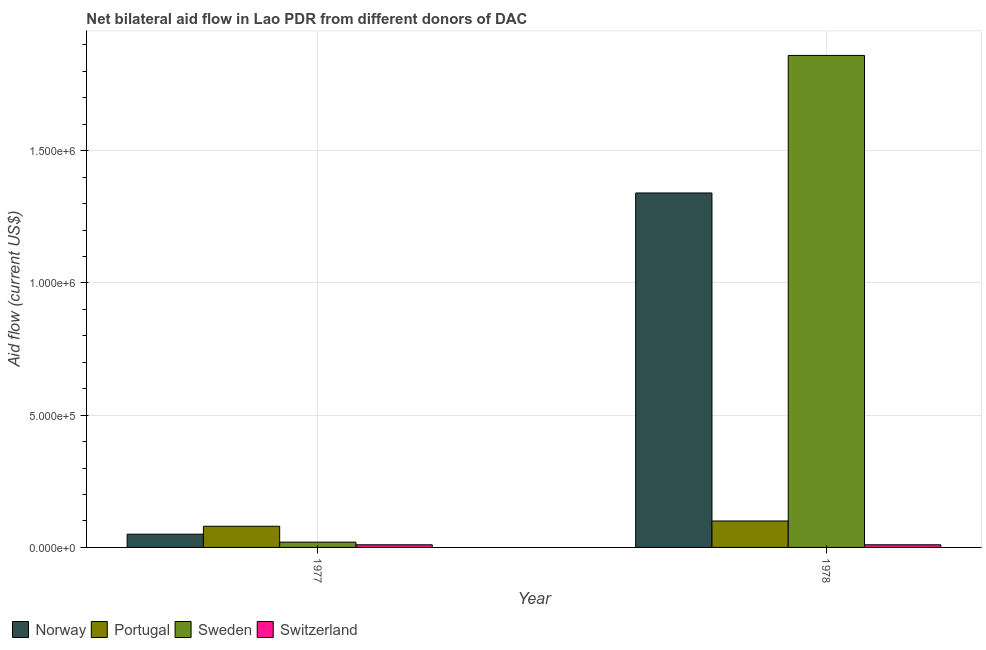How many different coloured bars are there?
Offer a very short reply. 4. How many groups of bars are there?
Provide a short and direct response. 2. How many bars are there on the 2nd tick from the left?
Make the answer very short. 4. What is the label of the 1st group of bars from the left?
Provide a short and direct response. 1977. In how many cases, is the number of bars for a given year not equal to the number of legend labels?
Ensure brevity in your answer.  0. What is the amount of aid given by sweden in 1978?
Your response must be concise. 1.86e+06. Across all years, what is the maximum amount of aid given by norway?
Offer a terse response. 1.34e+06. Across all years, what is the minimum amount of aid given by switzerland?
Your response must be concise. 10000. In which year was the amount of aid given by sweden maximum?
Your response must be concise. 1978. What is the total amount of aid given by switzerland in the graph?
Your response must be concise. 2.00e+04. What is the difference between the amount of aid given by norway in 1977 and that in 1978?
Make the answer very short. -1.29e+06. What is the difference between the amount of aid given by portugal in 1977 and the amount of aid given by sweden in 1978?
Provide a short and direct response. -2.00e+04. What is the average amount of aid given by portugal per year?
Offer a very short reply. 9.00e+04. In how many years, is the amount of aid given by portugal greater than 1300000 US$?
Offer a very short reply. 0. What is the ratio of the amount of aid given by switzerland in 1977 to that in 1978?
Provide a short and direct response. 1. Is the amount of aid given by sweden in 1977 less than that in 1978?
Ensure brevity in your answer.  Yes. In how many years, is the amount of aid given by portugal greater than the average amount of aid given by portugal taken over all years?
Ensure brevity in your answer.  1. Is it the case that in every year, the sum of the amount of aid given by switzerland and amount of aid given by norway is greater than the sum of amount of aid given by portugal and amount of aid given by sweden?
Make the answer very short. No. What does the 3rd bar from the left in 1977 represents?
Provide a succinct answer. Sweden. Is it the case that in every year, the sum of the amount of aid given by norway and amount of aid given by portugal is greater than the amount of aid given by sweden?
Ensure brevity in your answer.  No. How many years are there in the graph?
Give a very brief answer. 2. Does the graph contain any zero values?
Offer a very short reply. No. How are the legend labels stacked?
Make the answer very short. Horizontal. What is the title of the graph?
Keep it short and to the point. Net bilateral aid flow in Lao PDR from different donors of DAC. Does "Social Awareness" appear as one of the legend labels in the graph?
Ensure brevity in your answer.  No. What is the Aid flow (current US$) of Norway in 1977?
Give a very brief answer. 5.00e+04. What is the Aid flow (current US$) of Portugal in 1977?
Make the answer very short. 8.00e+04. What is the Aid flow (current US$) of Norway in 1978?
Provide a succinct answer. 1.34e+06. What is the Aid flow (current US$) of Sweden in 1978?
Your answer should be very brief. 1.86e+06. Across all years, what is the maximum Aid flow (current US$) in Norway?
Keep it short and to the point. 1.34e+06. Across all years, what is the maximum Aid flow (current US$) of Sweden?
Offer a very short reply. 1.86e+06. Across all years, what is the maximum Aid flow (current US$) of Switzerland?
Your response must be concise. 10000. Across all years, what is the minimum Aid flow (current US$) in Norway?
Your response must be concise. 5.00e+04. What is the total Aid flow (current US$) of Norway in the graph?
Ensure brevity in your answer.  1.39e+06. What is the total Aid flow (current US$) in Portugal in the graph?
Your answer should be compact. 1.80e+05. What is the total Aid flow (current US$) of Sweden in the graph?
Provide a short and direct response. 1.88e+06. What is the total Aid flow (current US$) of Switzerland in the graph?
Keep it short and to the point. 2.00e+04. What is the difference between the Aid flow (current US$) in Norway in 1977 and that in 1978?
Keep it short and to the point. -1.29e+06. What is the difference between the Aid flow (current US$) of Sweden in 1977 and that in 1978?
Your answer should be very brief. -1.84e+06. What is the difference between the Aid flow (current US$) of Switzerland in 1977 and that in 1978?
Provide a succinct answer. 0. What is the difference between the Aid flow (current US$) of Norway in 1977 and the Aid flow (current US$) of Portugal in 1978?
Your answer should be very brief. -5.00e+04. What is the difference between the Aid flow (current US$) in Norway in 1977 and the Aid flow (current US$) in Sweden in 1978?
Keep it short and to the point. -1.81e+06. What is the difference between the Aid flow (current US$) of Portugal in 1977 and the Aid flow (current US$) of Sweden in 1978?
Your answer should be very brief. -1.78e+06. What is the average Aid flow (current US$) in Norway per year?
Offer a very short reply. 6.95e+05. What is the average Aid flow (current US$) of Portugal per year?
Give a very brief answer. 9.00e+04. What is the average Aid flow (current US$) in Sweden per year?
Keep it short and to the point. 9.40e+05. What is the average Aid flow (current US$) in Switzerland per year?
Your answer should be compact. 10000. In the year 1977, what is the difference between the Aid flow (current US$) in Norway and Aid flow (current US$) in Portugal?
Your answer should be compact. -3.00e+04. In the year 1977, what is the difference between the Aid flow (current US$) in Norway and Aid flow (current US$) in Sweden?
Offer a terse response. 3.00e+04. In the year 1977, what is the difference between the Aid flow (current US$) of Norway and Aid flow (current US$) of Switzerland?
Make the answer very short. 4.00e+04. In the year 1977, what is the difference between the Aid flow (current US$) in Portugal and Aid flow (current US$) in Switzerland?
Give a very brief answer. 7.00e+04. In the year 1977, what is the difference between the Aid flow (current US$) in Sweden and Aid flow (current US$) in Switzerland?
Provide a short and direct response. 10000. In the year 1978, what is the difference between the Aid flow (current US$) in Norway and Aid flow (current US$) in Portugal?
Offer a terse response. 1.24e+06. In the year 1978, what is the difference between the Aid flow (current US$) of Norway and Aid flow (current US$) of Sweden?
Your answer should be compact. -5.20e+05. In the year 1978, what is the difference between the Aid flow (current US$) in Norway and Aid flow (current US$) in Switzerland?
Make the answer very short. 1.33e+06. In the year 1978, what is the difference between the Aid flow (current US$) of Portugal and Aid flow (current US$) of Sweden?
Ensure brevity in your answer.  -1.76e+06. In the year 1978, what is the difference between the Aid flow (current US$) in Portugal and Aid flow (current US$) in Switzerland?
Offer a very short reply. 9.00e+04. In the year 1978, what is the difference between the Aid flow (current US$) of Sweden and Aid flow (current US$) of Switzerland?
Your response must be concise. 1.85e+06. What is the ratio of the Aid flow (current US$) in Norway in 1977 to that in 1978?
Your answer should be very brief. 0.04. What is the ratio of the Aid flow (current US$) of Portugal in 1977 to that in 1978?
Make the answer very short. 0.8. What is the ratio of the Aid flow (current US$) in Sweden in 1977 to that in 1978?
Offer a very short reply. 0.01. What is the difference between the highest and the second highest Aid flow (current US$) in Norway?
Your answer should be compact. 1.29e+06. What is the difference between the highest and the second highest Aid flow (current US$) in Portugal?
Offer a terse response. 2.00e+04. What is the difference between the highest and the second highest Aid flow (current US$) in Sweden?
Keep it short and to the point. 1.84e+06. What is the difference between the highest and the lowest Aid flow (current US$) in Norway?
Offer a terse response. 1.29e+06. What is the difference between the highest and the lowest Aid flow (current US$) in Portugal?
Make the answer very short. 2.00e+04. What is the difference between the highest and the lowest Aid flow (current US$) of Sweden?
Give a very brief answer. 1.84e+06. What is the difference between the highest and the lowest Aid flow (current US$) in Switzerland?
Provide a succinct answer. 0. 